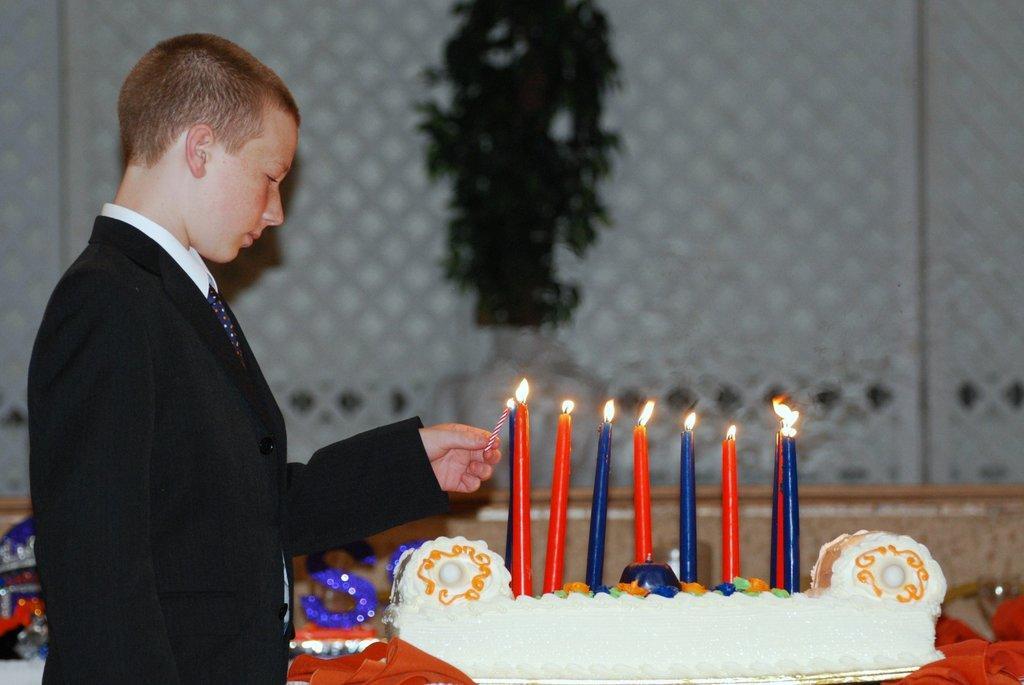Can you describe this image briefly? In this image I can see the person is holding a candle. In front I can see the cake and few candles on it. Back I can see few objects and the blurred background. 